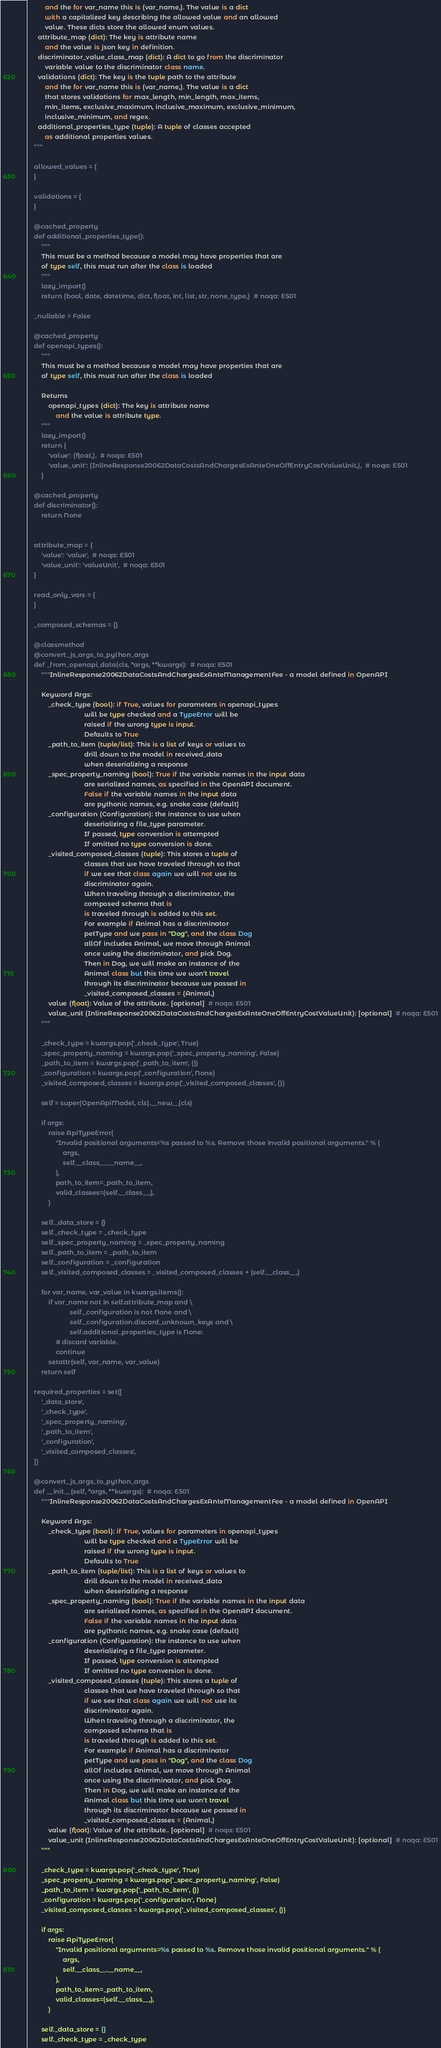<code> <loc_0><loc_0><loc_500><loc_500><_Python_>          and the for var_name this is (var_name,). The value is a dict
          with a capitalized key describing the allowed value and an allowed
          value. These dicts store the allowed enum values.
      attribute_map (dict): The key is attribute name
          and the value is json key in definition.
      discriminator_value_class_map (dict): A dict to go from the discriminator
          variable value to the discriminator class name.
      validations (dict): The key is the tuple path to the attribute
          and the for var_name this is (var_name,). The value is a dict
          that stores validations for max_length, min_length, max_items,
          min_items, exclusive_maximum, inclusive_maximum, exclusive_minimum,
          inclusive_minimum, and regex.
      additional_properties_type (tuple): A tuple of classes accepted
          as additional properties values.
    """

    allowed_values = {
    }

    validations = {
    }

    @cached_property
    def additional_properties_type():
        """
        This must be a method because a model may have properties that are
        of type self, this must run after the class is loaded
        """
        lazy_import()
        return (bool, date, datetime, dict, float, int, list, str, none_type,)  # noqa: E501

    _nullable = False

    @cached_property
    def openapi_types():
        """
        This must be a method because a model may have properties that are
        of type self, this must run after the class is loaded

        Returns
            openapi_types (dict): The key is attribute name
                and the value is attribute type.
        """
        lazy_import()
        return {
            'value': (float,),  # noqa: E501
            'value_unit': (InlineResponse20062DataCostsAndChargesExAnteOneOffEntryCostValueUnit,),  # noqa: E501
        }

    @cached_property
    def discriminator():
        return None


    attribute_map = {
        'value': 'value',  # noqa: E501
        'value_unit': 'valueUnit',  # noqa: E501
    }

    read_only_vars = {
    }

    _composed_schemas = {}

    @classmethod
    @convert_js_args_to_python_args
    def _from_openapi_data(cls, *args, **kwargs):  # noqa: E501
        """InlineResponse20062DataCostsAndChargesExAnteManagementFee - a model defined in OpenAPI

        Keyword Args:
            _check_type (bool): if True, values for parameters in openapi_types
                                will be type checked and a TypeError will be
                                raised if the wrong type is input.
                                Defaults to True
            _path_to_item (tuple/list): This is a list of keys or values to
                                drill down to the model in received_data
                                when deserializing a response
            _spec_property_naming (bool): True if the variable names in the input data
                                are serialized names, as specified in the OpenAPI document.
                                False if the variable names in the input data
                                are pythonic names, e.g. snake case (default)
            _configuration (Configuration): the instance to use when
                                deserializing a file_type parameter.
                                If passed, type conversion is attempted
                                If omitted no type conversion is done.
            _visited_composed_classes (tuple): This stores a tuple of
                                classes that we have traveled through so that
                                if we see that class again we will not use its
                                discriminator again.
                                When traveling through a discriminator, the
                                composed schema that is
                                is traveled through is added to this set.
                                For example if Animal has a discriminator
                                petType and we pass in "Dog", and the class Dog
                                allOf includes Animal, we move through Animal
                                once using the discriminator, and pick Dog.
                                Then in Dog, we will make an instance of the
                                Animal class but this time we won't travel
                                through its discriminator because we passed in
                                _visited_composed_classes = (Animal,)
            value (float): Value of the attribute.. [optional]  # noqa: E501
            value_unit (InlineResponse20062DataCostsAndChargesExAnteOneOffEntryCostValueUnit): [optional]  # noqa: E501
        """

        _check_type = kwargs.pop('_check_type', True)
        _spec_property_naming = kwargs.pop('_spec_property_naming', False)
        _path_to_item = kwargs.pop('_path_to_item', ())
        _configuration = kwargs.pop('_configuration', None)
        _visited_composed_classes = kwargs.pop('_visited_composed_classes', ())

        self = super(OpenApiModel, cls).__new__(cls)

        if args:
            raise ApiTypeError(
                "Invalid positional arguments=%s passed to %s. Remove those invalid positional arguments." % (
                    args,
                    self.__class__.__name__,
                ),
                path_to_item=_path_to_item,
                valid_classes=(self.__class__,),
            )

        self._data_store = {}
        self._check_type = _check_type
        self._spec_property_naming = _spec_property_naming
        self._path_to_item = _path_to_item
        self._configuration = _configuration
        self._visited_composed_classes = _visited_composed_classes + (self.__class__,)

        for var_name, var_value in kwargs.items():
            if var_name not in self.attribute_map and \
                        self._configuration is not None and \
                        self._configuration.discard_unknown_keys and \
                        self.additional_properties_type is None:
                # discard variable.
                continue
            setattr(self, var_name, var_value)
        return self

    required_properties = set([
        '_data_store',
        '_check_type',
        '_spec_property_naming',
        '_path_to_item',
        '_configuration',
        '_visited_composed_classes',
    ])

    @convert_js_args_to_python_args
    def __init__(self, *args, **kwargs):  # noqa: E501
        """InlineResponse20062DataCostsAndChargesExAnteManagementFee - a model defined in OpenAPI

        Keyword Args:
            _check_type (bool): if True, values for parameters in openapi_types
                                will be type checked and a TypeError will be
                                raised if the wrong type is input.
                                Defaults to True
            _path_to_item (tuple/list): This is a list of keys or values to
                                drill down to the model in received_data
                                when deserializing a response
            _spec_property_naming (bool): True if the variable names in the input data
                                are serialized names, as specified in the OpenAPI document.
                                False if the variable names in the input data
                                are pythonic names, e.g. snake case (default)
            _configuration (Configuration): the instance to use when
                                deserializing a file_type parameter.
                                If passed, type conversion is attempted
                                If omitted no type conversion is done.
            _visited_composed_classes (tuple): This stores a tuple of
                                classes that we have traveled through so that
                                if we see that class again we will not use its
                                discriminator again.
                                When traveling through a discriminator, the
                                composed schema that is
                                is traveled through is added to this set.
                                For example if Animal has a discriminator
                                petType and we pass in "Dog", and the class Dog
                                allOf includes Animal, we move through Animal
                                once using the discriminator, and pick Dog.
                                Then in Dog, we will make an instance of the
                                Animal class but this time we won't travel
                                through its discriminator because we passed in
                                _visited_composed_classes = (Animal,)
            value (float): Value of the attribute.. [optional]  # noqa: E501
            value_unit (InlineResponse20062DataCostsAndChargesExAnteOneOffEntryCostValueUnit): [optional]  # noqa: E501
        """

        _check_type = kwargs.pop('_check_type', True)
        _spec_property_naming = kwargs.pop('_spec_property_naming', False)
        _path_to_item = kwargs.pop('_path_to_item', ())
        _configuration = kwargs.pop('_configuration', None)
        _visited_composed_classes = kwargs.pop('_visited_composed_classes', ())

        if args:
            raise ApiTypeError(
                "Invalid positional arguments=%s passed to %s. Remove those invalid positional arguments." % (
                    args,
                    self.__class__.__name__,
                ),
                path_to_item=_path_to_item,
                valid_classes=(self.__class__,),
            )

        self._data_store = {}
        self._check_type = _check_type</code> 